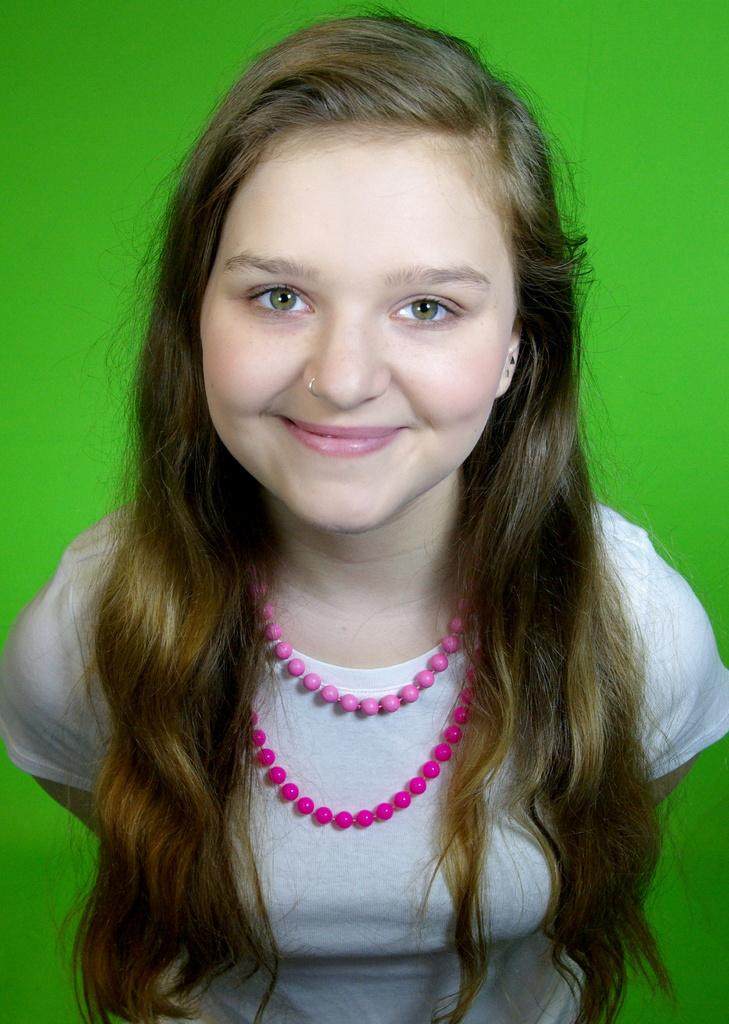Who is the main subject in the foreground of the image? There is a woman in the foreground of the image. What is the woman wearing around her neck? The woman is wearing a pink color chain around her neck. What color dominates the background of the image? The background of the image is green. What type of steel desk can be seen in the image? There is no steel desk present in the image. 